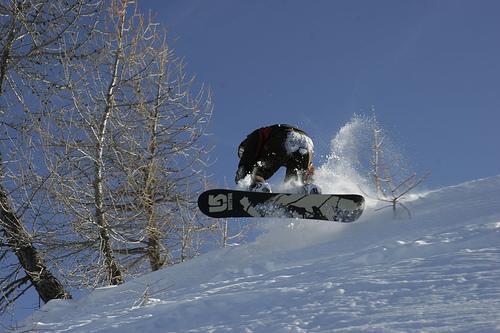Is the tree bare?
Keep it brief. Yes. What sport is he doing?
Write a very short answer. Snowboarding. Has the man fallen?
Be succinct. No. How many people are airborne?
Short answer required. 1. What are the people doing?
Quick response, please. Snowboarding. 